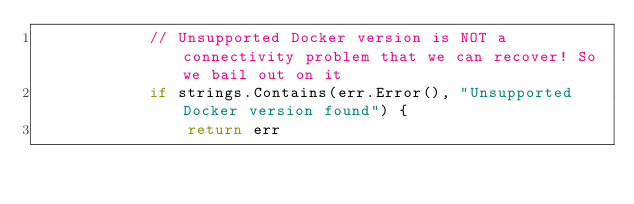Convert code to text. <code><loc_0><loc_0><loc_500><loc_500><_Go_>			// Unsupported Docker version is NOT a connectivity problem that we can recover! So we bail out on it
			if strings.Contains(err.Error(), "Unsupported Docker version found") {
				return err</code> 